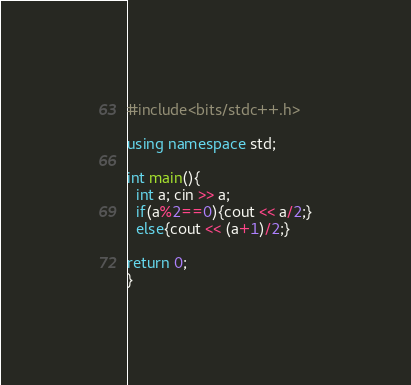<code> <loc_0><loc_0><loc_500><loc_500><_C++_>#include<bits/stdc++.h>

using namespace std;

int main(){
  int a; cin >> a;
  if(a%2==0){cout << a/2;}
  else{cout << (a+1)/2;}

return 0;
}</code> 